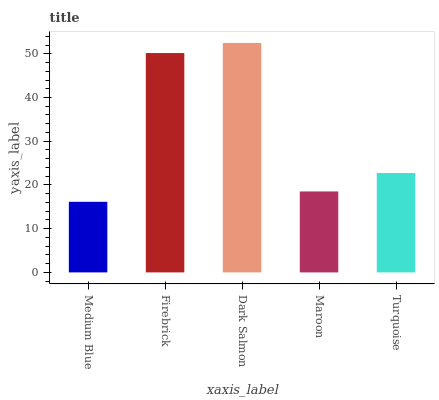Is Medium Blue the minimum?
Answer yes or no. Yes. Is Dark Salmon the maximum?
Answer yes or no. Yes. Is Firebrick the minimum?
Answer yes or no. No. Is Firebrick the maximum?
Answer yes or no. No. Is Firebrick greater than Medium Blue?
Answer yes or no. Yes. Is Medium Blue less than Firebrick?
Answer yes or no. Yes. Is Medium Blue greater than Firebrick?
Answer yes or no. No. Is Firebrick less than Medium Blue?
Answer yes or no. No. Is Turquoise the high median?
Answer yes or no. Yes. Is Turquoise the low median?
Answer yes or no. Yes. Is Dark Salmon the high median?
Answer yes or no. No. Is Firebrick the low median?
Answer yes or no. No. 